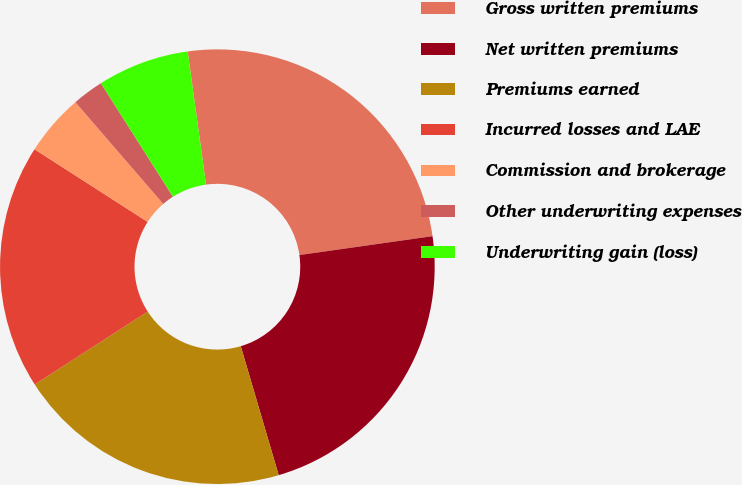<chart> <loc_0><loc_0><loc_500><loc_500><pie_chart><fcel>Gross written premiums<fcel>Net written premiums<fcel>Premiums earned<fcel>Incurred losses and LAE<fcel>Commission and brokerage<fcel>Other underwriting expenses<fcel>Underwriting gain (loss)<nl><fcel>24.94%<fcel>22.69%<fcel>20.44%<fcel>18.2%<fcel>4.58%<fcel>2.33%<fcel>6.82%<nl></chart> 